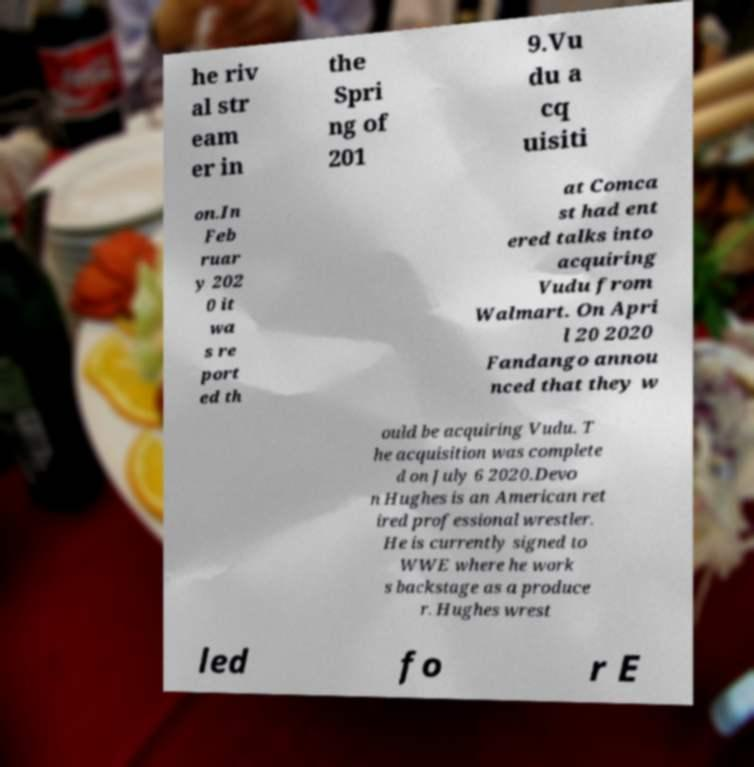Please identify and transcribe the text found in this image. he riv al str eam er in the Spri ng of 201 9.Vu du a cq uisiti on.In Feb ruar y 202 0 it wa s re port ed th at Comca st had ent ered talks into acquiring Vudu from Walmart. On Apri l 20 2020 Fandango annou nced that they w ould be acquiring Vudu. T he acquisition was complete d on July 6 2020.Devo n Hughes is an American ret ired professional wrestler. He is currently signed to WWE where he work s backstage as a produce r. Hughes wrest led fo r E 